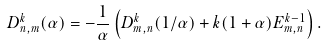<formula> <loc_0><loc_0><loc_500><loc_500>D ^ { k } _ { n , m } ( \alpha ) = - \frac { 1 } { \alpha } \left ( D ^ { k } _ { m , n } ( 1 / \alpha ) + k ( 1 + \alpha ) E ^ { k - 1 } _ { m , n } \right ) .</formula> 